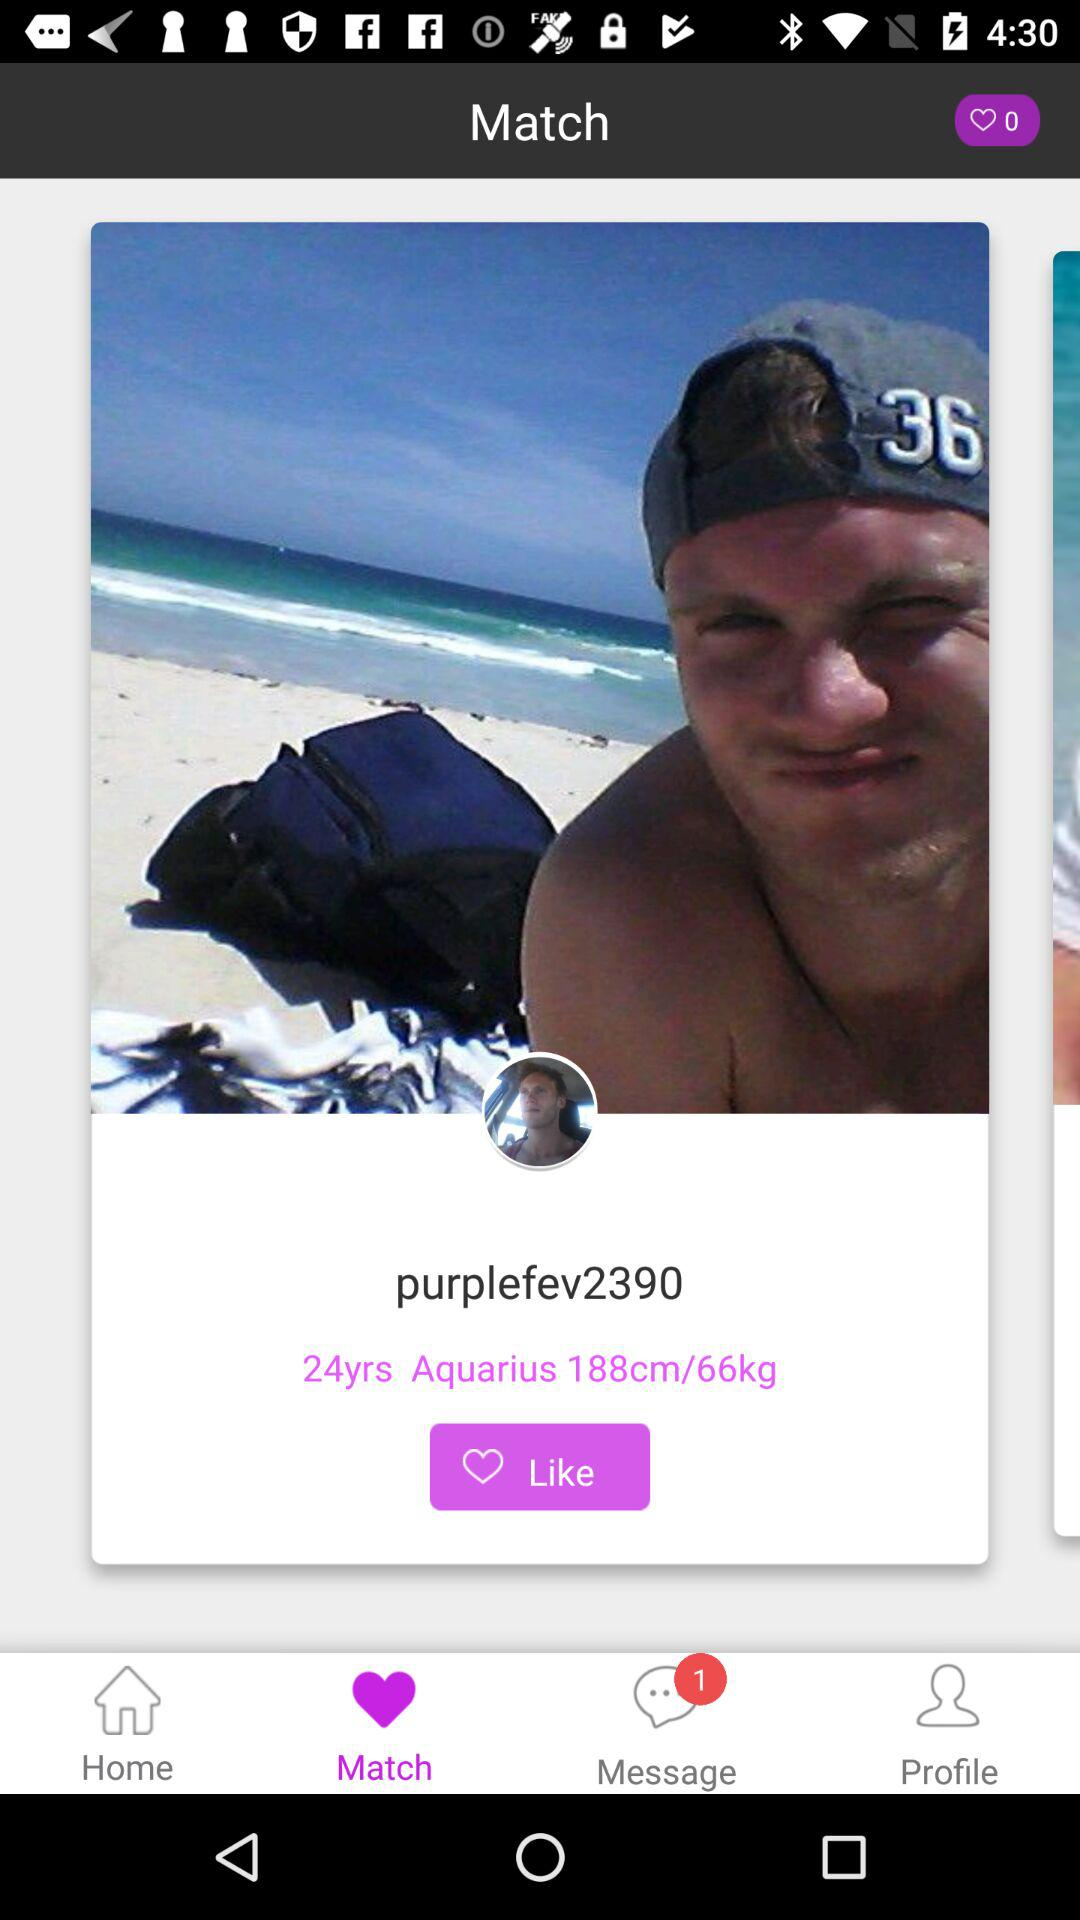What is the astrological sign of "purplefev2390"? The astrological sign is "Aquarius". 